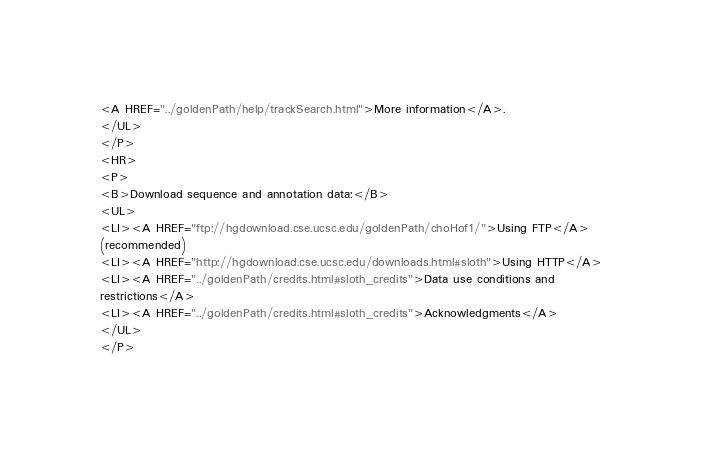<code> <loc_0><loc_0><loc_500><loc_500><_HTML_><A HREF="../goldenPath/help/trackSearch.html">More information</A>.
</UL>
</P>
<HR>
<P>
<B>Download sequence and annotation data:</B>
<UL>
<LI><A HREF="ftp://hgdownload.cse.ucsc.edu/goldenPath/choHof1/">Using FTP</A>
(recommended)
<LI><A HREF="http://hgdownload.cse.ucsc.edu/downloads.html#sloth">Using HTTP</A>
<LI><A HREF="../goldenPath/credits.html#sloth_credits">Data use conditions and
restrictions</A>
<LI><A HREF="../goldenPath/credits.html#sloth_credits">Acknowledgments</A>
</UL>
</P>
</code> 